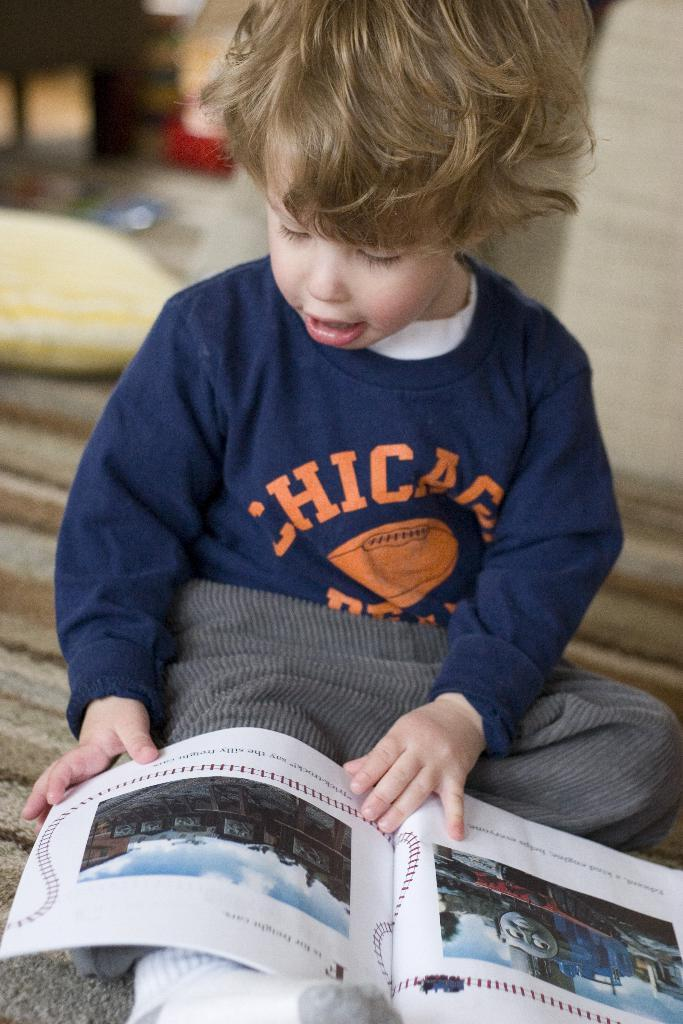Who is the main subject in the image? There is a boy in the image. What is the boy doing in the image? The boy is sitting. What is the boy holding in the image? The boy is holding a book. What can be seen in the background of the image? There is a pillow and a wall in the background of the image, as well as other objects. What type of toothpaste is the boy using in the image? There is no toothpaste present in the image. Can you tell me how the boy is touching the wall in the image? The boy is not touching the wall in the image; he is sitting and holding a book. 